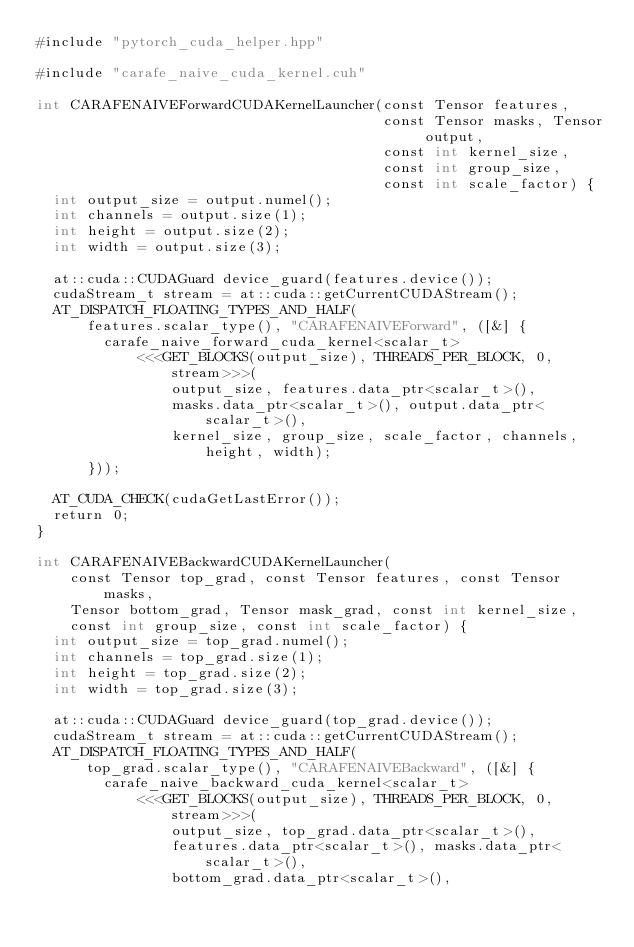<code> <loc_0><loc_0><loc_500><loc_500><_Cuda_>#include "pytorch_cuda_helper.hpp"

#include "carafe_naive_cuda_kernel.cuh"

int CARAFENAIVEForwardCUDAKernelLauncher(const Tensor features,
                                         const Tensor masks, Tensor output,
                                         const int kernel_size,
                                         const int group_size,
                                         const int scale_factor) {
  int output_size = output.numel();
  int channels = output.size(1);
  int height = output.size(2);
  int width = output.size(3);

  at::cuda::CUDAGuard device_guard(features.device());
  cudaStream_t stream = at::cuda::getCurrentCUDAStream();
  AT_DISPATCH_FLOATING_TYPES_AND_HALF(
      features.scalar_type(), "CARAFENAIVEForward", ([&] {
        carafe_naive_forward_cuda_kernel<scalar_t>
            <<<GET_BLOCKS(output_size), THREADS_PER_BLOCK, 0, stream>>>(
                output_size, features.data_ptr<scalar_t>(),
                masks.data_ptr<scalar_t>(), output.data_ptr<scalar_t>(),
                kernel_size, group_size, scale_factor, channels, height, width);
      }));

  AT_CUDA_CHECK(cudaGetLastError());
  return 0;
}

int CARAFENAIVEBackwardCUDAKernelLauncher(
    const Tensor top_grad, const Tensor features, const Tensor masks,
    Tensor bottom_grad, Tensor mask_grad, const int kernel_size,
    const int group_size, const int scale_factor) {
  int output_size = top_grad.numel();
  int channels = top_grad.size(1);
  int height = top_grad.size(2);
  int width = top_grad.size(3);

  at::cuda::CUDAGuard device_guard(top_grad.device());
  cudaStream_t stream = at::cuda::getCurrentCUDAStream();
  AT_DISPATCH_FLOATING_TYPES_AND_HALF(
      top_grad.scalar_type(), "CARAFENAIVEBackward", ([&] {
        carafe_naive_backward_cuda_kernel<scalar_t>
            <<<GET_BLOCKS(output_size), THREADS_PER_BLOCK, 0, stream>>>(
                output_size, top_grad.data_ptr<scalar_t>(),
                features.data_ptr<scalar_t>(), masks.data_ptr<scalar_t>(),
                bottom_grad.data_ptr<scalar_t>(),</code> 